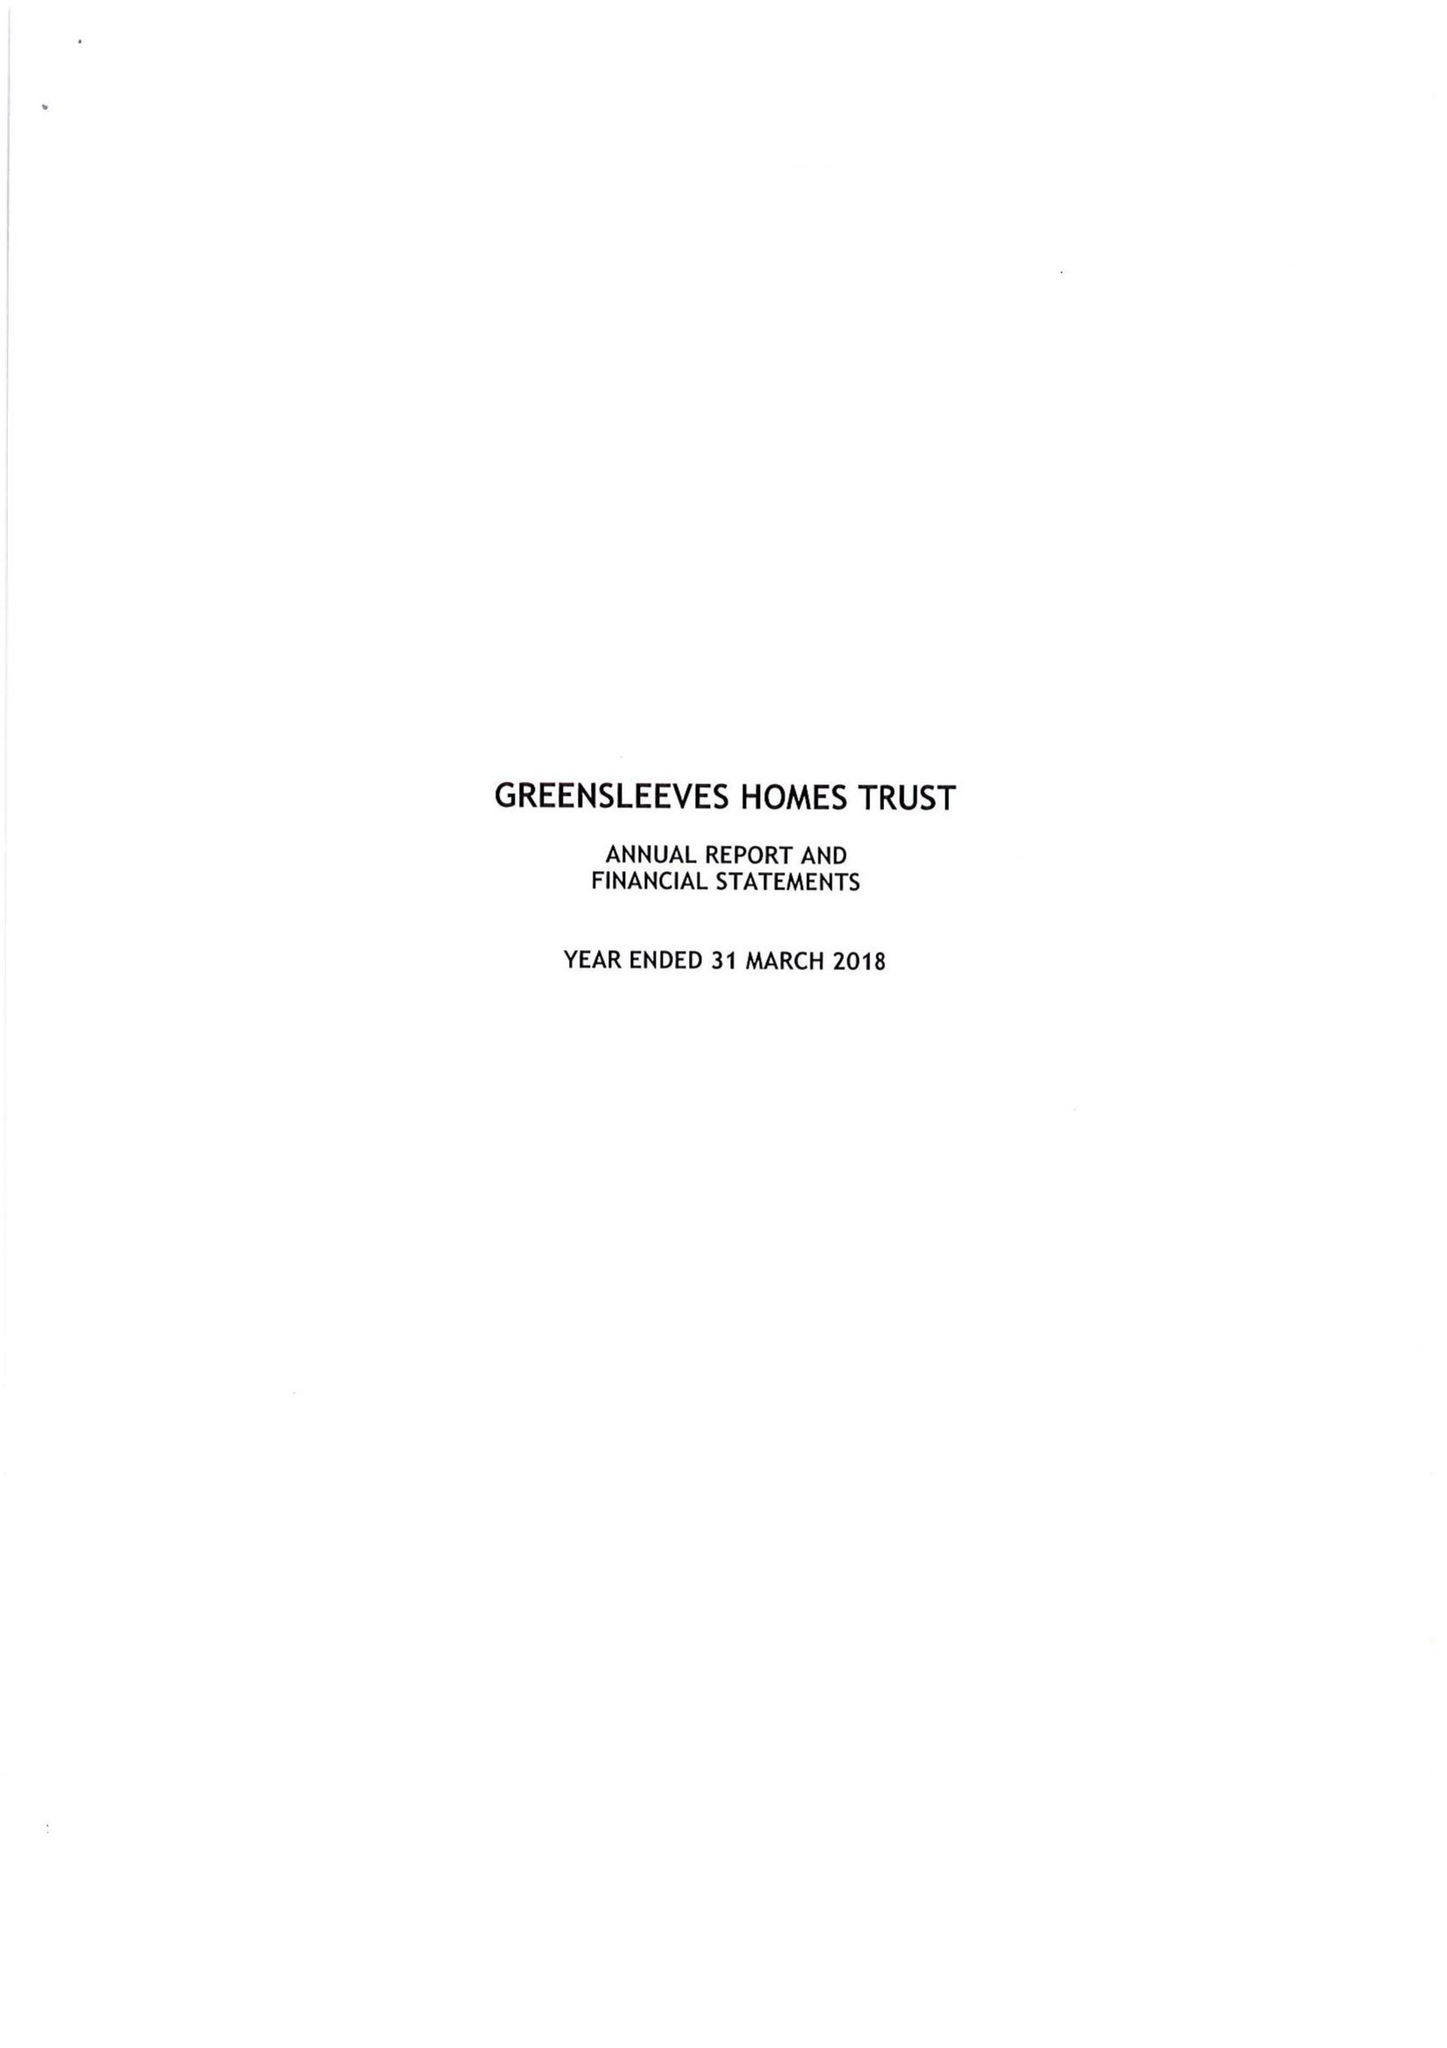What is the value for the report_date?
Answer the question using a single word or phrase. 2018-03-31 